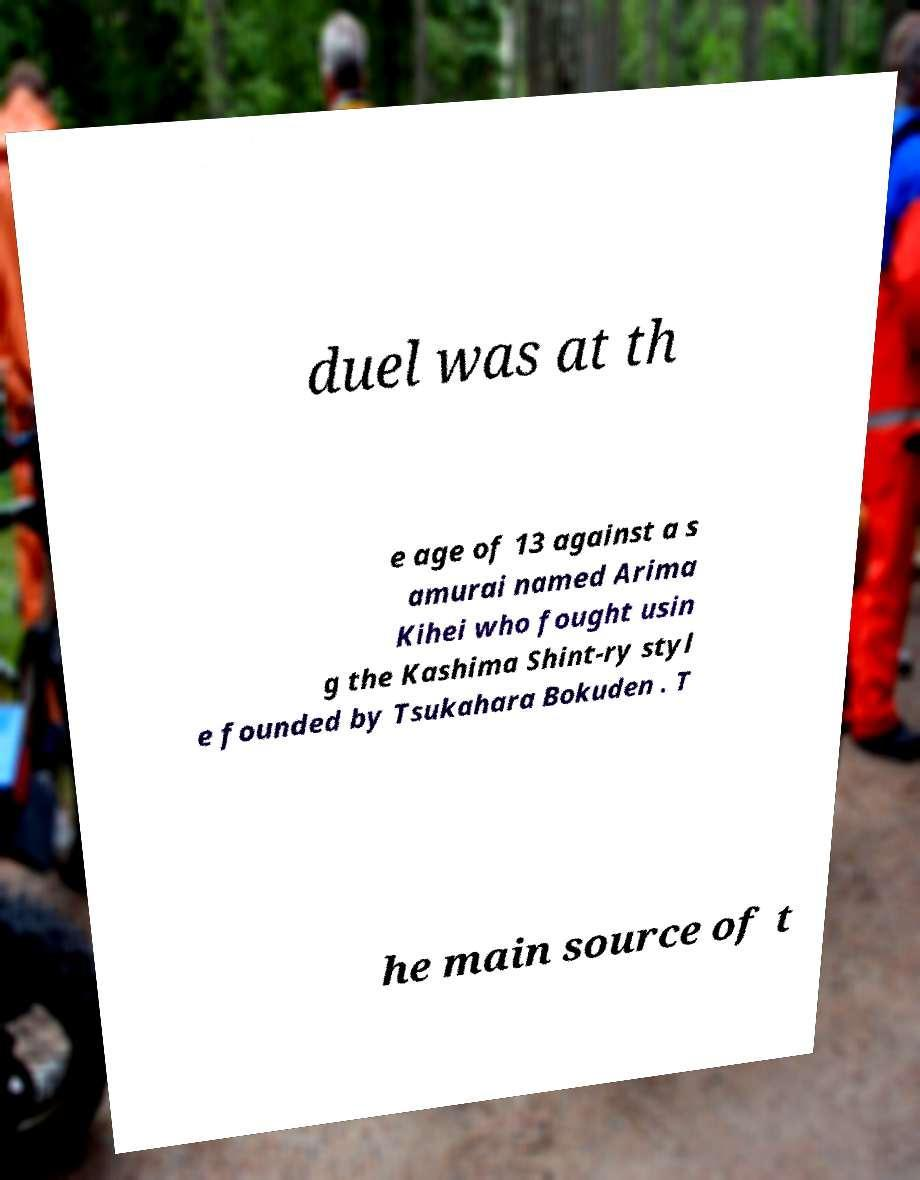Could you assist in decoding the text presented in this image and type it out clearly? duel was at th e age of 13 against a s amurai named Arima Kihei who fought usin g the Kashima Shint-ry styl e founded by Tsukahara Bokuden . T he main source of t 